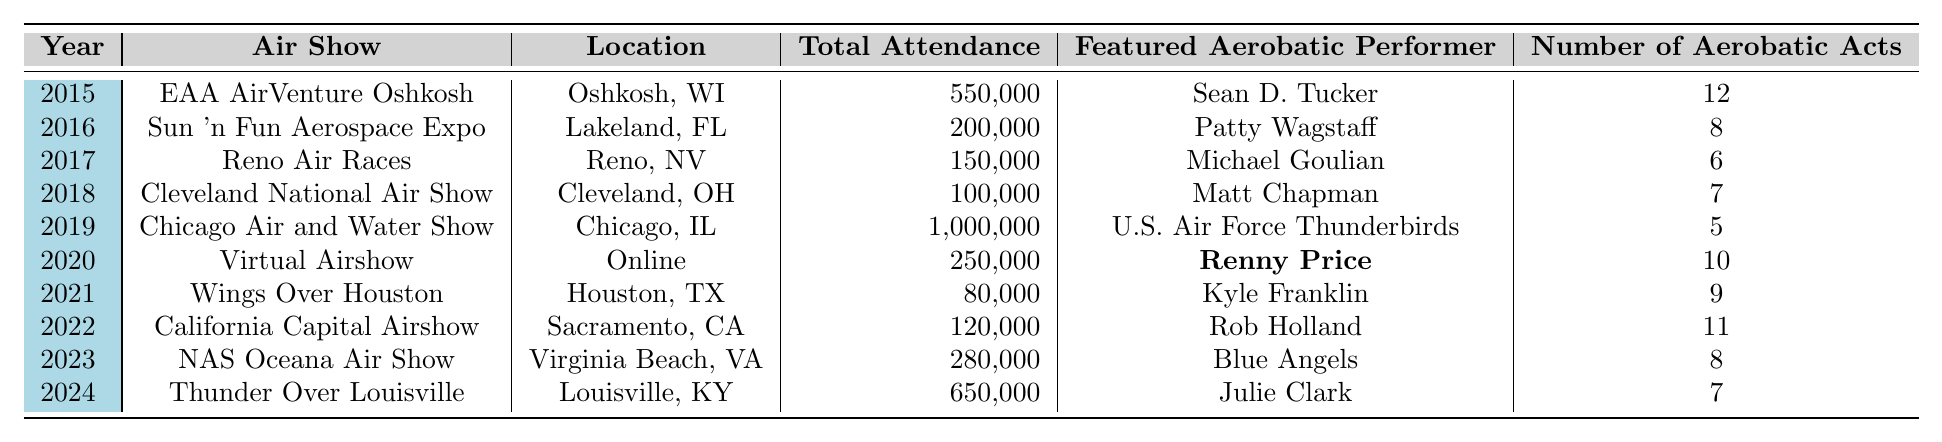What was the total attendance at the Chicago Air and Water Show in 2019? The table shows that the total attendance for the Chicago Air and Water Show in 2019 was 1,000,000.
Answer: 1,000,000 Who was the featured aerobatic performer at the 2020 Virtual Airshow? According to the table, the featured aerobatic performer for the Virtual Airshow in 2020 was Renny Price.
Answer: Renny Price In which year did the California Capital Airshow take place? The table indicates that the California Capital Airshow took place in 2022.
Answer: 2022 What is the average attendance of the air shows from 2015 to 2024? To find the average, first sum the total attendance for all years: 550,000 + 200,000 + 150,000 + 100,000 + 1,000,000 + 250,000 + 80,000 + 120,000 + 280,000 + 650,000 = 3,480,000. There are 10 air shows, so the average attendance is 3,480,000 / 10 = 348,000.
Answer: 348,000 Which air show had the least attendance, and what was that number? The table shows that the Wings Over Houston air show in 2021 had the least attendance, with a total of 80,000.
Answer: 80,000 Was there an air show held online in 2020? Yes, the table indicates that there was an air show called Virtual Airshow held online in 2020.
Answer: Yes Which air show in 2023 had the Blue Angels as the featured aerobatic performer, and what was its attendance? The NAS Oceana Air Show held in 2023 featured the Blue Angels, and its attendance was 280,000 according to the table.
Answer: NAS Oceana Air Show, 280,000 How many total aerobatic acts were presented at the EAA AirVenture Oshkosh in 2015? The table states that there were 12 aerobatic acts at the EAA AirVenture Oshkosh in 2015.
Answer: 12 Which air show had the most aerobatic acts, and how many were there? The EAA AirVenture Oshkosh in 2015 had the most aerobatic acts, totaling 12 as noted in the table.
Answer: EAA AirVenture Oshkosh, 12 What was the total attendance for the air shows from 2019 to 2024? To calculate the total attendance from 2019 to 2024, sum the attendances: 1,000,000 (2019) + 250,000 (2020) + 80,000 (2021) + 120,000 (2022) + 280,000 (2023) + 650,000 (2024) = 2,380,000.
Answer: 2,380,000 How many air shows had a featured performer named Matt? The table shows that there is one air show featuring a performer named Matt (Matt Chapman at Cleveland National Air Show in 2018).
Answer: 1 